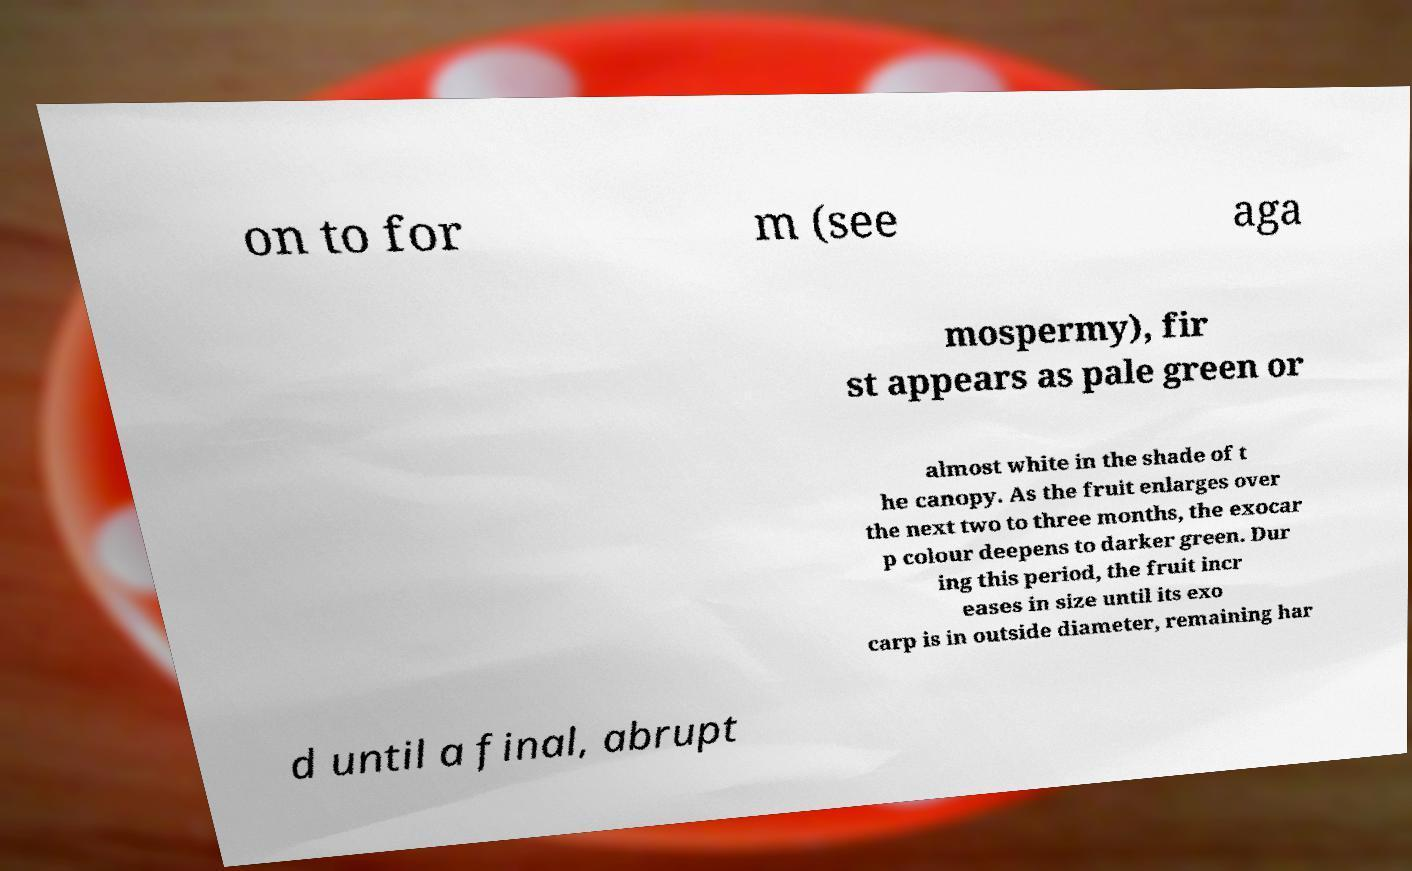Can you accurately transcribe the text from the provided image for me? on to for m (see aga mospermy), fir st appears as pale green or almost white in the shade of t he canopy. As the fruit enlarges over the next two to three months, the exocar p colour deepens to darker green. Dur ing this period, the fruit incr eases in size until its exo carp is in outside diameter, remaining har d until a final, abrupt 